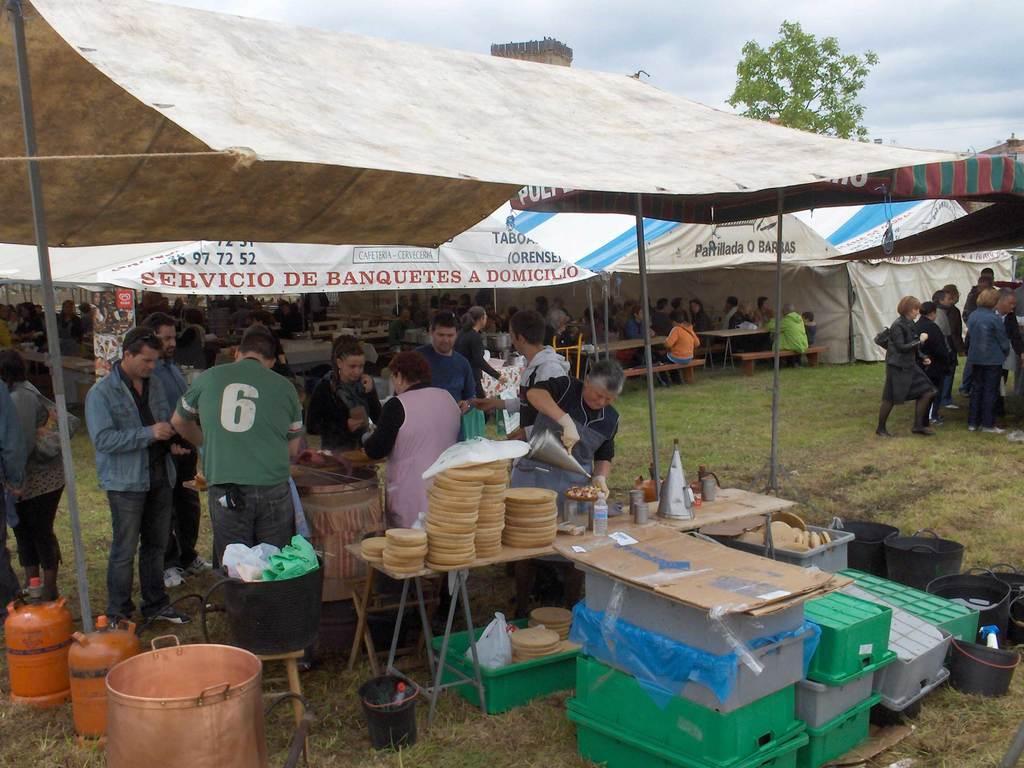Could you give a brief overview of what you see in this image? In this image we can see a few people some of them are sitting on benches, there are tables, on one table there are plates, glasses, jugs, there are buckets, tins, boxes, there are some food items in a box, there are tents, we can see text on some tents, there is a board with some text on it, there is a tree, also we can see the sky, and a person holding a jug. 